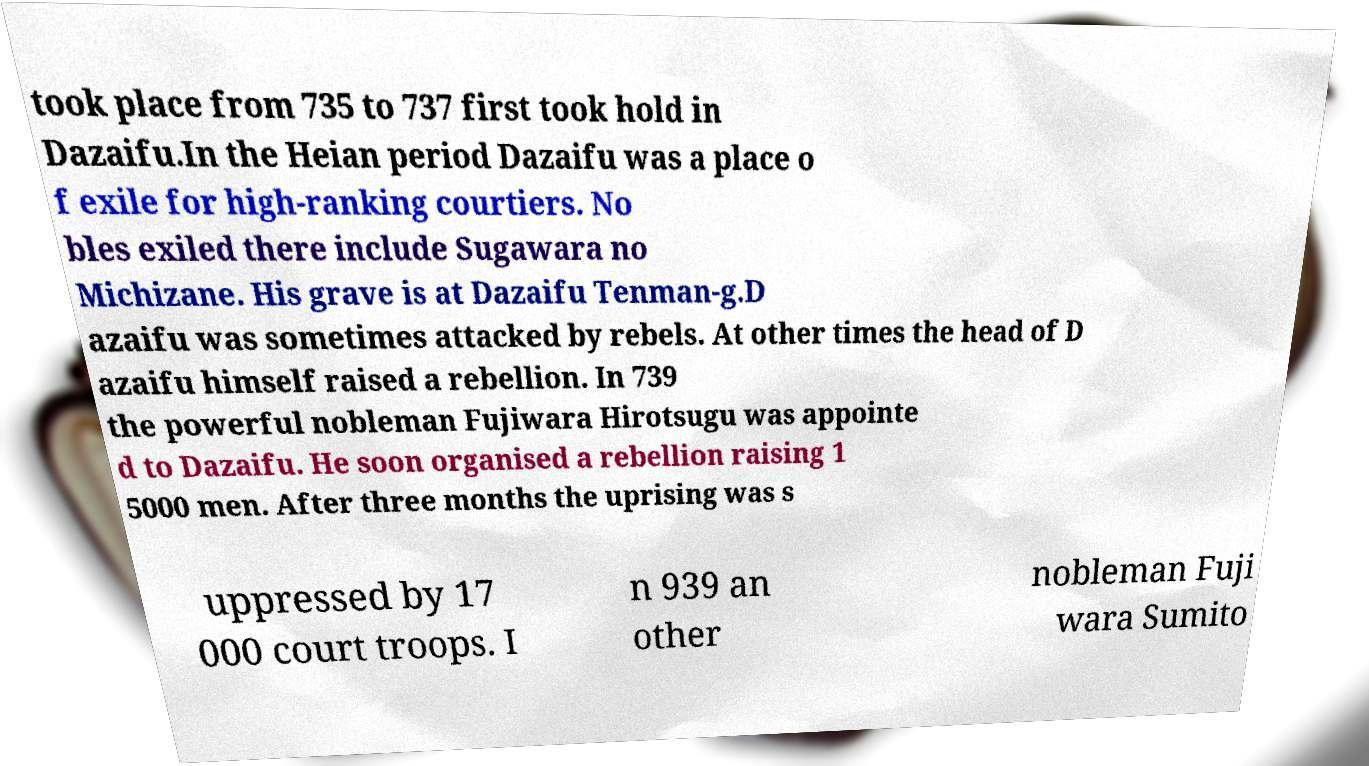Could you assist in decoding the text presented in this image and type it out clearly? took place from 735 to 737 first took hold in Dazaifu.In the Heian period Dazaifu was a place o f exile for high-ranking courtiers. No bles exiled there include Sugawara no Michizane. His grave is at Dazaifu Tenman-g.D azaifu was sometimes attacked by rebels. At other times the head of D azaifu himself raised a rebellion. In 739 the powerful nobleman Fujiwara Hirotsugu was appointe d to Dazaifu. He soon organised a rebellion raising 1 5000 men. After three months the uprising was s uppressed by 17 000 court troops. I n 939 an other nobleman Fuji wara Sumito 